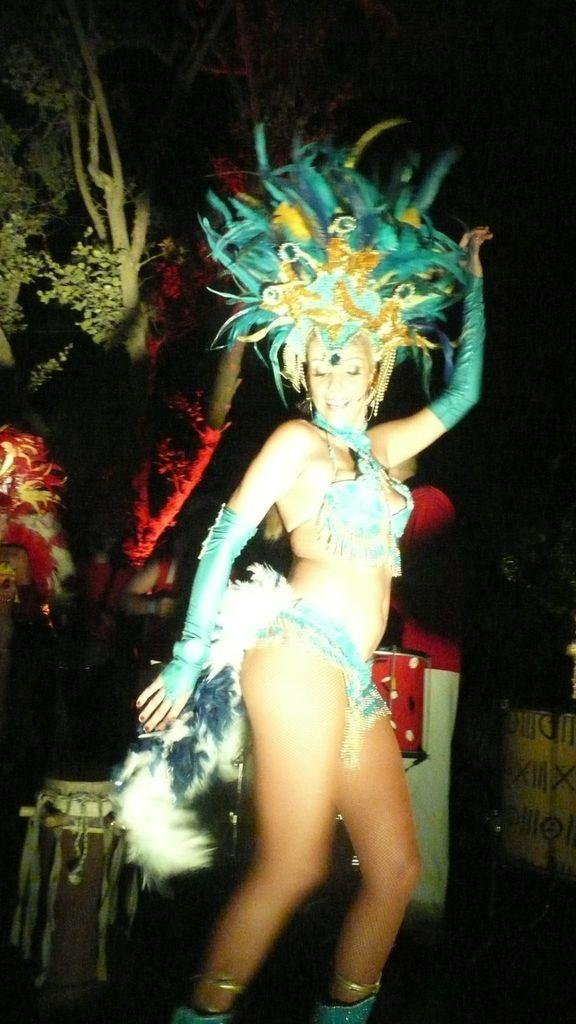Who is the main subject in the image? There is a woman in the image. What is the woman wearing? The woman is wearing a fancy dress. What is the woman doing in the image? The woman is dancing. What musical instrument can be seen in the image? There are drums in the image. What type of natural element is present in the image? There is a tree in the image. Can you tell me which actor is performing in the wilderness in the image? There is no actor performing in the wilderness in the image; it features a woman dancing and drums. 